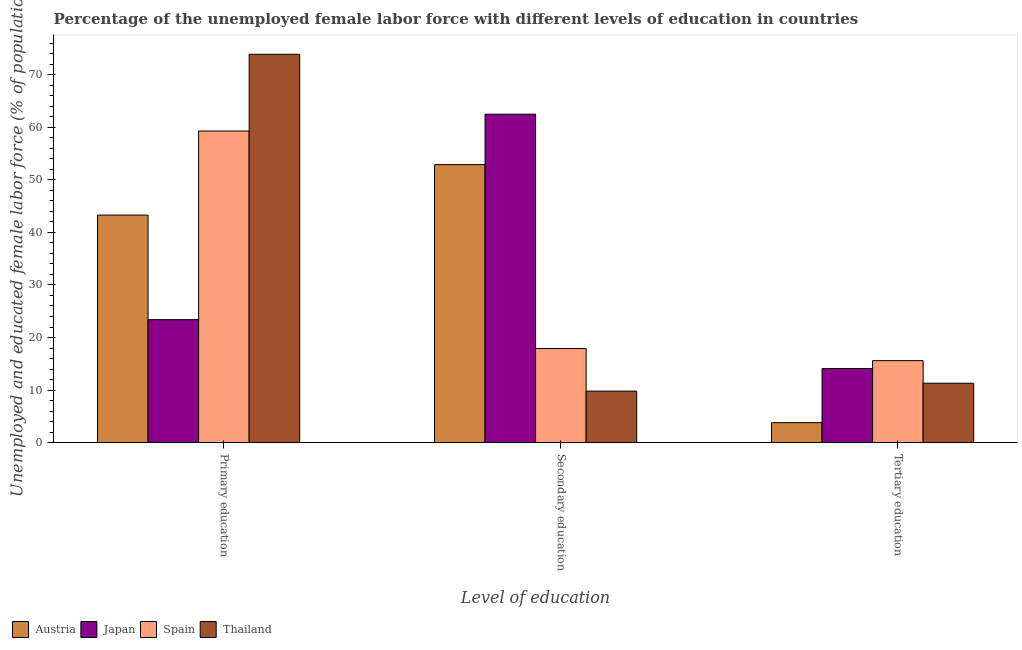How many different coloured bars are there?
Make the answer very short. 4. How many groups of bars are there?
Provide a short and direct response. 3. How many bars are there on the 2nd tick from the left?
Offer a terse response. 4. What is the label of the 1st group of bars from the left?
Ensure brevity in your answer.  Primary education. What is the percentage of female labor force who received secondary education in Thailand?
Ensure brevity in your answer.  9.8. Across all countries, what is the maximum percentage of female labor force who received secondary education?
Give a very brief answer. 62.5. Across all countries, what is the minimum percentage of female labor force who received tertiary education?
Make the answer very short. 3.8. In which country was the percentage of female labor force who received secondary education maximum?
Your response must be concise. Japan. In which country was the percentage of female labor force who received tertiary education minimum?
Offer a very short reply. Austria. What is the total percentage of female labor force who received tertiary education in the graph?
Your answer should be very brief. 44.8. What is the difference between the percentage of female labor force who received secondary education in Japan and that in Austria?
Your response must be concise. 9.6. What is the difference between the percentage of female labor force who received primary education in Japan and the percentage of female labor force who received secondary education in Spain?
Keep it short and to the point. 5.5. What is the average percentage of female labor force who received secondary education per country?
Offer a terse response. 35.78. What is the difference between the percentage of female labor force who received tertiary education and percentage of female labor force who received primary education in Austria?
Offer a terse response. -39.5. What is the ratio of the percentage of female labor force who received secondary education in Japan to that in Spain?
Make the answer very short. 3.49. Is the difference between the percentage of female labor force who received secondary education in Spain and Thailand greater than the difference between the percentage of female labor force who received primary education in Spain and Thailand?
Give a very brief answer. Yes. What is the difference between the highest and the second highest percentage of female labor force who received tertiary education?
Make the answer very short. 1.5. What is the difference between the highest and the lowest percentage of female labor force who received primary education?
Your answer should be compact. 50.5. Is the sum of the percentage of female labor force who received secondary education in Japan and Austria greater than the maximum percentage of female labor force who received tertiary education across all countries?
Your answer should be compact. Yes. What does the 3rd bar from the left in Tertiary education represents?
Provide a short and direct response. Spain. What does the 4th bar from the right in Tertiary education represents?
Provide a short and direct response. Austria. How many bars are there?
Offer a terse response. 12. Are all the bars in the graph horizontal?
Provide a succinct answer. No. How many countries are there in the graph?
Give a very brief answer. 4. Are the values on the major ticks of Y-axis written in scientific E-notation?
Your answer should be compact. No. Where does the legend appear in the graph?
Ensure brevity in your answer.  Bottom left. How are the legend labels stacked?
Ensure brevity in your answer.  Horizontal. What is the title of the graph?
Your response must be concise. Percentage of the unemployed female labor force with different levels of education in countries. What is the label or title of the X-axis?
Make the answer very short. Level of education. What is the label or title of the Y-axis?
Make the answer very short. Unemployed and educated female labor force (% of population). What is the Unemployed and educated female labor force (% of population) in Austria in Primary education?
Provide a succinct answer. 43.3. What is the Unemployed and educated female labor force (% of population) in Japan in Primary education?
Your answer should be very brief. 23.4. What is the Unemployed and educated female labor force (% of population) of Spain in Primary education?
Keep it short and to the point. 59.3. What is the Unemployed and educated female labor force (% of population) in Thailand in Primary education?
Keep it short and to the point. 73.9. What is the Unemployed and educated female labor force (% of population) of Austria in Secondary education?
Give a very brief answer. 52.9. What is the Unemployed and educated female labor force (% of population) in Japan in Secondary education?
Your response must be concise. 62.5. What is the Unemployed and educated female labor force (% of population) in Spain in Secondary education?
Offer a terse response. 17.9. What is the Unemployed and educated female labor force (% of population) of Thailand in Secondary education?
Offer a very short reply. 9.8. What is the Unemployed and educated female labor force (% of population) in Austria in Tertiary education?
Your answer should be compact. 3.8. What is the Unemployed and educated female labor force (% of population) in Japan in Tertiary education?
Offer a very short reply. 14.1. What is the Unemployed and educated female labor force (% of population) in Spain in Tertiary education?
Provide a succinct answer. 15.6. What is the Unemployed and educated female labor force (% of population) of Thailand in Tertiary education?
Your response must be concise. 11.3. Across all Level of education, what is the maximum Unemployed and educated female labor force (% of population) in Austria?
Offer a terse response. 52.9. Across all Level of education, what is the maximum Unemployed and educated female labor force (% of population) of Japan?
Offer a terse response. 62.5. Across all Level of education, what is the maximum Unemployed and educated female labor force (% of population) in Spain?
Your response must be concise. 59.3. Across all Level of education, what is the maximum Unemployed and educated female labor force (% of population) in Thailand?
Keep it short and to the point. 73.9. Across all Level of education, what is the minimum Unemployed and educated female labor force (% of population) in Austria?
Provide a succinct answer. 3.8. Across all Level of education, what is the minimum Unemployed and educated female labor force (% of population) in Japan?
Provide a succinct answer. 14.1. Across all Level of education, what is the minimum Unemployed and educated female labor force (% of population) in Spain?
Keep it short and to the point. 15.6. Across all Level of education, what is the minimum Unemployed and educated female labor force (% of population) of Thailand?
Provide a short and direct response. 9.8. What is the total Unemployed and educated female labor force (% of population) of Austria in the graph?
Provide a succinct answer. 100. What is the total Unemployed and educated female labor force (% of population) in Japan in the graph?
Offer a very short reply. 100. What is the total Unemployed and educated female labor force (% of population) in Spain in the graph?
Offer a terse response. 92.8. What is the total Unemployed and educated female labor force (% of population) in Thailand in the graph?
Provide a short and direct response. 95. What is the difference between the Unemployed and educated female labor force (% of population) of Japan in Primary education and that in Secondary education?
Offer a terse response. -39.1. What is the difference between the Unemployed and educated female labor force (% of population) in Spain in Primary education and that in Secondary education?
Provide a succinct answer. 41.4. What is the difference between the Unemployed and educated female labor force (% of population) in Thailand in Primary education and that in Secondary education?
Provide a short and direct response. 64.1. What is the difference between the Unemployed and educated female labor force (% of population) of Austria in Primary education and that in Tertiary education?
Your answer should be compact. 39.5. What is the difference between the Unemployed and educated female labor force (% of population) in Japan in Primary education and that in Tertiary education?
Your response must be concise. 9.3. What is the difference between the Unemployed and educated female labor force (% of population) of Spain in Primary education and that in Tertiary education?
Your response must be concise. 43.7. What is the difference between the Unemployed and educated female labor force (% of population) in Thailand in Primary education and that in Tertiary education?
Offer a terse response. 62.6. What is the difference between the Unemployed and educated female labor force (% of population) of Austria in Secondary education and that in Tertiary education?
Give a very brief answer. 49.1. What is the difference between the Unemployed and educated female labor force (% of population) of Japan in Secondary education and that in Tertiary education?
Ensure brevity in your answer.  48.4. What is the difference between the Unemployed and educated female labor force (% of population) of Spain in Secondary education and that in Tertiary education?
Offer a terse response. 2.3. What is the difference between the Unemployed and educated female labor force (% of population) of Thailand in Secondary education and that in Tertiary education?
Your answer should be very brief. -1.5. What is the difference between the Unemployed and educated female labor force (% of population) in Austria in Primary education and the Unemployed and educated female labor force (% of population) in Japan in Secondary education?
Your answer should be compact. -19.2. What is the difference between the Unemployed and educated female labor force (% of population) in Austria in Primary education and the Unemployed and educated female labor force (% of population) in Spain in Secondary education?
Your answer should be compact. 25.4. What is the difference between the Unemployed and educated female labor force (% of population) of Austria in Primary education and the Unemployed and educated female labor force (% of population) of Thailand in Secondary education?
Make the answer very short. 33.5. What is the difference between the Unemployed and educated female labor force (% of population) of Japan in Primary education and the Unemployed and educated female labor force (% of population) of Spain in Secondary education?
Give a very brief answer. 5.5. What is the difference between the Unemployed and educated female labor force (% of population) of Japan in Primary education and the Unemployed and educated female labor force (% of population) of Thailand in Secondary education?
Keep it short and to the point. 13.6. What is the difference between the Unemployed and educated female labor force (% of population) of Spain in Primary education and the Unemployed and educated female labor force (% of population) of Thailand in Secondary education?
Offer a terse response. 49.5. What is the difference between the Unemployed and educated female labor force (% of population) in Austria in Primary education and the Unemployed and educated female labor force (% of population) in Japan in Tertiary education?
Offer a very short reply. 29.2. What is the difference between the Unemployed and educated female labor force (% of population) in Austria in Primary education and the Unemployed and educated female labor force (% of population) in Spain in Tertiary education?
Offer a very short reply. 27.7. What is the difference between the Unemployed and educated female labor force (% of population) in Austria in Primary education and the Unemployed and educated female labor force (% of population) in Thailand in Tertiary education?
Your response must be concise. 32. What is the difference between the Unemployed and educated female labor force (% of population) in Japan in Primary education and the Unemployed and educated female labor force (% of population) in Spain in Tertiary education?
Give a very brief answer. 7.8. What is the difference between the Unemployed and educated female labor force (% of population) of Japan in Primary education and the Unemployed and educated female labor force (% of population) of Thailand in Tertiary education?
Give a very brief answer. 12.1. What is the difference between the Unemployed and educated female labor force (% of population) in Austria in Secondary education and the Unemployed and educated female labor force (% of population) in Japan in Tertiary education?
Keep it short and to the point. 38.8. What is the difference between the Unemployed and educated female labor force (% of population) in Austria in Secondary education and the Unemployed and educated female labor force (% of population) in Spain in Tertiary education?
Ensure brevity in your answer.  37.3. What is the difference between the Unemployed and educated female labor force (% of population) of Austria in Secondary education and the Unemployed and educated female labor force (% of population) of Thailand in Tertiary education?
Give a very brief answer. 41.6. What is the difference between the Unemployed and educated female labor force (% of population) in Japan in Secondary education and the Unemployed and educated female labor force (% of population) in Spain in Tertiary education?
Make the answer very short. 46.9. What is the difference between the Unemployed and educated female labor force (% of population) of Japan in Secondary education and the Unemployed and educated female labor force (% of population) of Thailand in Tertiary education?
Provide a short and direct response. 51.2. What is the difference between the Unemployed and educated female labor force (% of population) in Spain in Secondary education and the Unemployed and educated female labor force (% of population) in Thailand in Tertiary education?
Offer a very short reply. 6.6. What is the average Unemployed and educated female labor force (% of population) of Austria per Level of education?
Provide a succinct answer. 33.33. What is the average Unemployed and educated female labor force (% of population) in Japan per Level of education?
Keep it short and to the point. 33.33. What is the average Unemployed and educated female labor force (% of population) of Spain per Level of education?
Your answer should be very brief. 30.93. What is the average Unemployed and educated female labor force (% of population) of Thailand per Level of education?
Keep it short and to the point. 31.67. What is the difference between the Unemployed and educated female labor force (% of population) in Austria and Unemployed and educated female labor force (% of population) in Thailand in Primary education?
Provide a succinct answer. -30.6. What is the difference between the Unemployed and educated female labor force (% of population) of Japan and Unemployed and educated female labor force (% of population) of Spain in Primary education?
Your answer should be compact. -35.9. What is the difference between the Unemployed and educated female labor force (% of population) of Japan and Unemployed and educated female labor force (% of population) of Thailand in Primary education?
Provide a short and direct response. -50.5. What is the difference between the Unemployed and educated female labor force (% of population) of Spain and Unemployed and educated female labor force (% of population) of Thailand in Primary education?
Your response must be concise. -14.6. What is the difference between the Unemployed and educated female labor force (% of population) in Austria and Unemployed and educated female labor force (% of population) in Thailand in Secondary education?
Give a very brief answer. 43.1. What is the difference between the Unemployed and educated female labor force (% of population) of Japan and Unemployed and educated female labor force (% of population) of Spain in Secondary education?
Your answer should be very brief. 44.6. What is the difference between the Unemployed and educated female labor force (% of population) of Japan and Unemployed and educated female labor force (% of population) of Thailand in Secondary education?
Provide a short and direct response. 52.7. What is the difference between the Unemployed and educated female labor force (% of population) in Austria and Unemployed and educated female labor force (% of population) in Japan in Tertiary education?
Make the answer very short. -10.3. What is the difference between the Unemployed and educated female labor force (% of population) in Austria and Unemployed and educated female labor force (% of population) in Spain in Tertiary education?
Provide a short and direct response. -11.8. What is the difference between the Unemployed and educated female labor force (% of population) of Japan and Unemployed and educated female labor force (% of population) of Spain in Tertiary education?
Give a very brief answer. -1.5. What is the difference between the Unemployed and educated female labor force (% of population) of Japan and Unemployed and educated female labor force (% of population) of Thailand in Tertiary education?
Make the answer very short. 2.8. What is the difference between the Unemployed and educated female labor force (% of population) in Spain and Unemployed and educated female labor force (% of population) in Thailand in Tertiary education?
Keep it short and to the point. 4.3. What is the ratio of the Unemployed and educated female labor force (% of population) in Austria in Primary education to that in Secondary education?
Your answer should be very brief. 0.82. What is the ratio of the Unemployed and educated female labor force (% of population) in Japan in Primary education to that in Secondary education?
Offer a terse response. 0.37. What is the ratio of the Unemployed and educated female labor force (% of population) of Spain in Primary education to that in Secondary education?
Provide a succinct answer. 3.31. What is the ratio of the Unemployed and educated female labor force (% of population) of Thailand in Primary education to that in Secondary education?
Provide a short and direct response. 7.54. What is the ratio of the Unemployed and educated female labor force (% of population) of Austria in Primary education to that in Tertiary education?
Provide a short and direct response. 11.39. What is the ratio of the Unemployed and educated female labor force (% of population) of Japan in Primary education to that in Tertiary education?
Offer a terse response. 1.66. What is the ratio of the Unemployed and educated female labor force (% of population) of Spain in Primary education to that in Tertiary education?
Offer a terse response. 3.8. What is the ratio of the Unemployed and educated female labor force (% of population) of Thailand in Primary education to that in Tertiary education?
Give a very brief answer. 6.54. What is the ratio of the Unemployed and educated female labor force (% of population) in Austria in Secondary education to that in Tertiary education?
Keep it short and to the point. 13.92. What is the ratio of the Unemployed and educated female labor force (% of population) in Japan in Secondary education to that in Tertiary education?
Offer a very short reply. 4.43. What is the ratio of the Unemployed and educated female labor force (% of population) of Spain in Secondary education to that in Tertiary education?
Make the answer very short. 1.15. What is the ratio of the Unemployed and educated female labor force (% of population) of Thailand in Secondary education to that in Tertiary education?
Keep it short and to the point. 0.87. What is the difference between the highest and the second highest Unemployed and educated female labor force (% of population) in Austria?
Your response must be concise. 9.6. What is the difference between the highest and the second highest Unemployed and educated female labor force (% of population) of Japan?
Provide a succinct answer. 39.1. What is the difference between the highest and the second highest Unemployed and educated female labor force (% of population) of Spain?
Keep it short and to the point. 41.4. What is the difference between the highest and the second highest Unemployed and educated female labor force (% of population) of Thailand?
Keep it short and to the point. 62.6. What is the difference between the highest and the lowest Unemployed and educated female labor force (% of population) of Austria?
Give a very brief answer. 49.1. What is the difference between the highest and the lowest Unemployed and educated female labor force (% of population) of Japan?
Your response must be concise. 48.4. What is the difference between the highest and the lowest Unemployed and educated female labor force (% of population) in Spain?
Your answer should be compact. 43.7. What is the difference between the highest and the lowest Unemployed and educated female labor force (% of population) of Thailand?
Your answer should be compact. 64.1. 